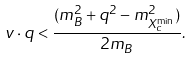<formula> <loc_0><loc_0><loc_500><loc_500>v \cdot q < \frac { ( m _ { B } ^ { 2 } + q ^ { 2 } - m _ { X _ { c } ^ { \min } } ^ { 2 } ) } { 2 m _ { B } } .</formula> 